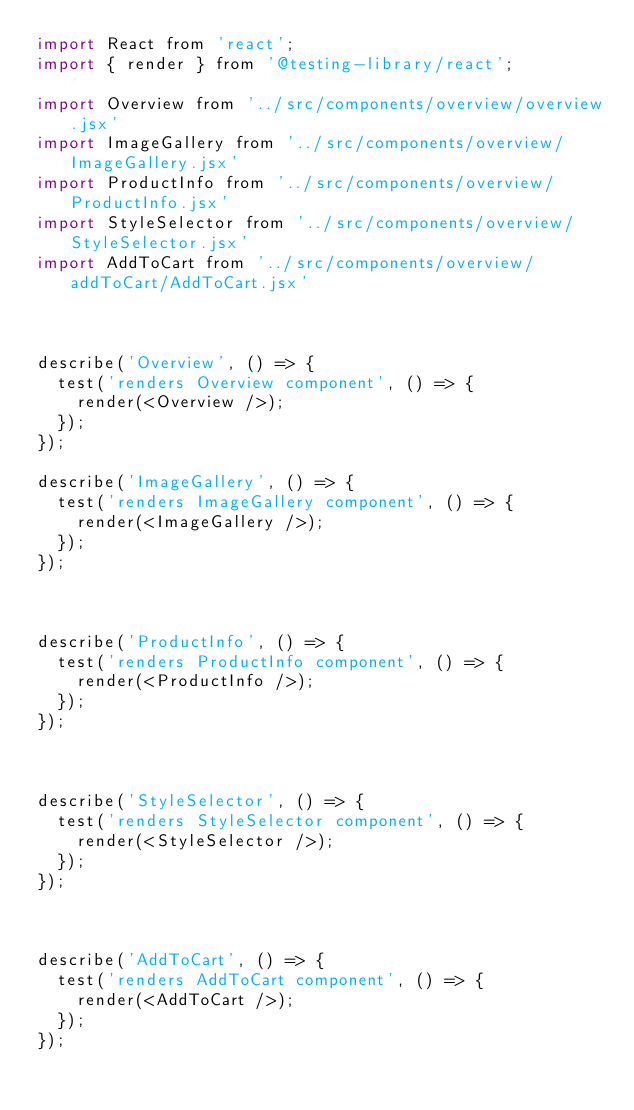<code> <loc_0><loc_0><loc_500><loc_500><_JavaScript_>import React from 'react';
import { render } from '@testing-library/react';

import Overview from '../src/components/overview/overview.jsx'
import ImageGallery from '../src/components/overview/ImageGallery.jsx'
import ProductInfo from '../src/components/overview/ProductInfo.jsx'
import StyleSelector from '../src/components/overview/StyleSelector.jsx'
import AddToCart from '../src/components/overview/addToCart/AddToCart.jsx'



describe('Overview', () => {
  test('renders Overview component', () => {
    render(<Overview />);
  });
});

describe('ImageGallery', () => {
  test('renders ImageGallery component', () => {
    render(<ImageGallery />);
  });
});



describe('ProductInfo', () => {
  test('renders ProductInfo component', () => {
    render(<ProductInfo />);
  });
});



describe('StyleSelector', () => {
  test('renders StyleSelector component', () => {
    render(<StyleSelector />);
  });
});



describe('AddToCart', () => {
  test('renders AddToCart component', () => {
    render(<AddToCart />);
  });
});





</code> 